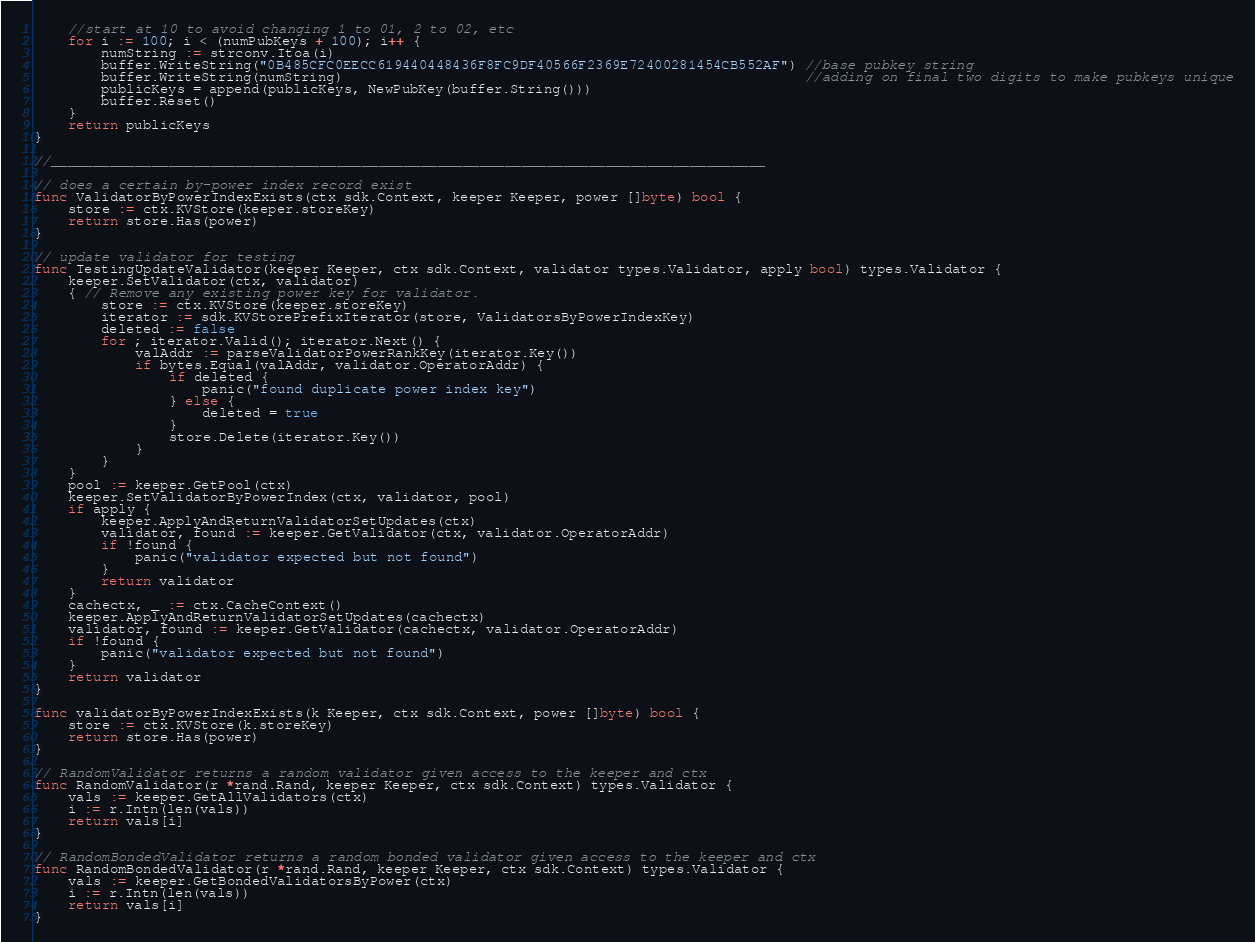Convert code to text. <code><loc_0><loc_0><loc_500><loc_500><_Go_>	//start at 10 to avoid changing 1 to 01, 2 to 02, etc
	for i := 100; i < (numPubKeys + 100); i++ {
		numString := strconv.Itoa(i)
		buffer.WriteString("0B485CFC0EECC619440448436F8FC9DF40566F2369E72400281454CB552AF") //base pubkey string
		buffer.WriteString(numString)                                                       //adding on final two digits to make pubkeys unique
		publicKeys = append(publicKeys, NewPubKey(buffer.String()))
		buffer.Reset()
	}
	return publicKeys
}

//_____________________________________________________________________________________

// does a certain by-power index record exist
func ValidatorByPowerIndexExists(ctx sdk.Context, keeper Keeper, power []byte) bool {
	store := ctx.KVStore(keeper.storeKey)
	return store.Has(power)
}

// update validator for testing
func TestingUpdateValidator(keeper Keeper, ctx sdk.Context, validator types.Validator, apply bool) types.Validator {
	keeper.SetValidator(ctx, validator)
	{ // Remove any existing power key for validator.
		store := ctx.KVStore(keeper.storeKey)
		iterator := sdk.KVStorePrefixIterator(store, ValidatorsByPowerIndexKey)
		deleted := false
		for ; iterator.Valid(); iterator.Next() {
			valAddr := parseValidatorPowerRankKey(iterator.Key())
			if bytes.Equal(valAddr, validator.OperatorAddr) {
				if deleted {
					panic("found duplicate power index key")
				} else {
					deleted = true
				}
				store.Delete(iterator.Key())
			}
		}
	}
	pool := keeper.GetPool(ctx)
	keeper.SetValidatorByPowerIndex(ctx, validator, pool)
	if apply {
		keeper.ApplyAndReturnValidatorSetUpdates(ctx)
		validator, found := keeper.GetValidator(ctx, validator.OperatorAddr)
		if !found {
			panic("validator expected but not found")
		}
		return validator
	}
	cachectx, _ := ctx.CacheContext()
	keeper.ApplyAndReturnValidatorSetUpdates(cachectx)
	validator, found := keeper.GetValidator(cachectx, validator.OperatorAddr)
	if !found {
		panic("validator expected but not found")
	}
	return validator
}

func validatorByPowerIndexExists(k Keeper, ctx sdk.Context, power []byte) bool {
	store := ctx.KVStore(k.storeKey)
	return store.Has(power)
}

// RandomValidator returns a random validator given access to the keeper and ctx
func RandomValidator(r *rand.Rand, keeper Keeper, ctx sdk.Context) types.Validator {
	vals := keeper.GetAllValidators(ctx)
	i := r.Intn(len(vals))
	return vals[i]
}

// RandomBondedValidator returns a random bonded validator given access to the keeper and ctx
func RandomBondedValidator(r *rand.Rand, keeper Keeper, ctx sdk.Context) types.Validator {
	vals := keeper.GetBondedValidatorsByPower(ctx)
	i := r.Intn(len(vals))
	return vals[i]
}
</code> 